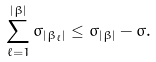Convert formula to latex. <formula><loc_0><loc_0><loc_500><loc_500>\sum _ { \ell = 1 } ^ { | \beta | } \sigma _ { | \beta _ { \ell } | } \leq \sigma _ { | \beta | } - \sigma .</formula> 